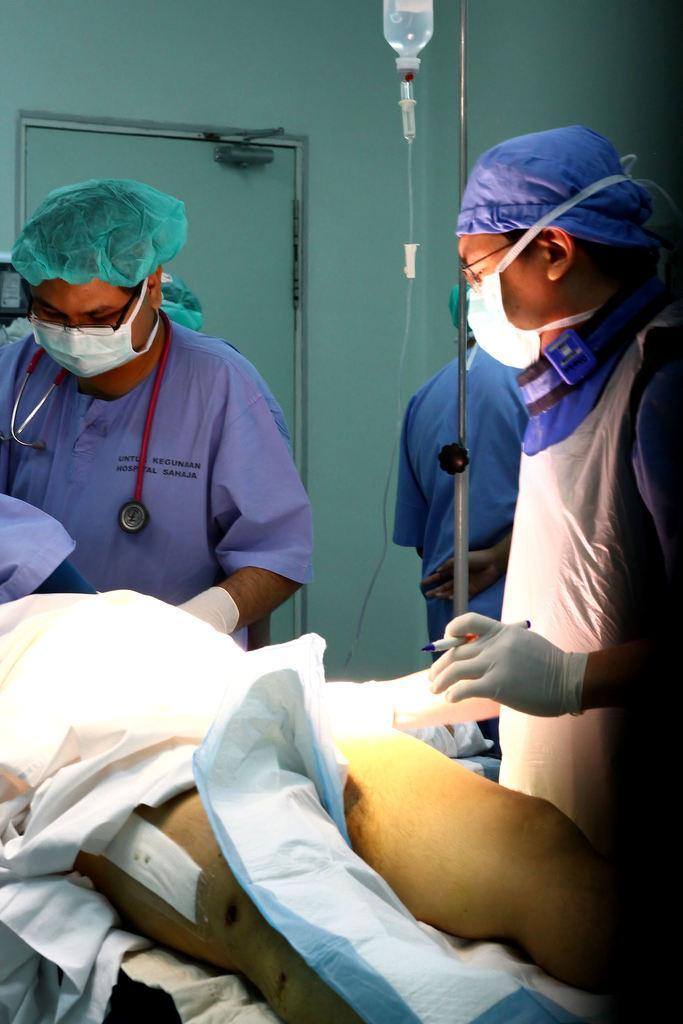Describe this image in one or two sentences. In this image it looks like there are two doctors who are doing the operation. In the middle there is a saline. In the background there is a door. The two doctors are wearing the masks and stethoscope. The doctor on the right side is holding the pen. At the bottom there is a blanket on the body. 